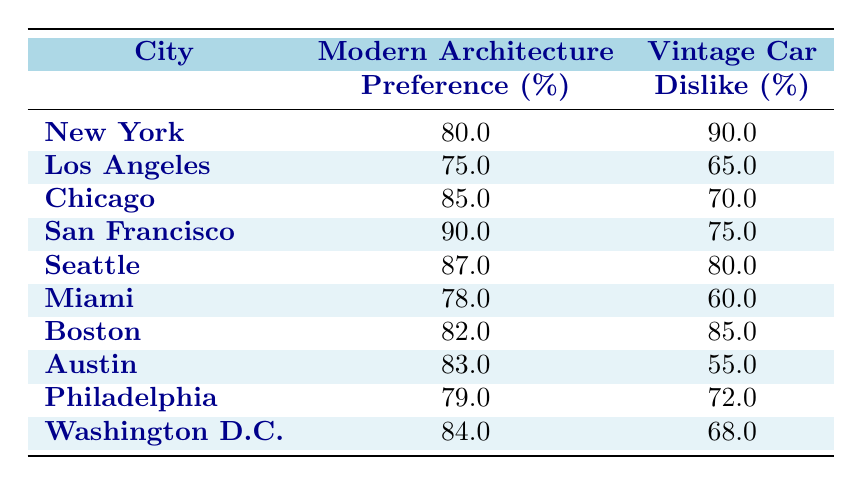What is the modern architecture preference percentage for San Francisco? The table shows that San Francisco has a modern architecture preference of 90%.
Answer: 90.0 What is the vintage car dislike percentage for Miami? According to the table, Miami has a vintage car dislike percentage of 60%.
Answer: 60.0 Which city has the highest vintage car dislike percentage? By looking through the table, New York exhibits the highest vintage car dislike at 90%.
Answer: New York What is the average modern architecture preference percentage across all cities? To find the average, we can add the modern architecture preferences: 80 + 75 + 85 + 90 + 87 + 78 + 82 + 83 + 79 + 84 =  834. There are 10 cities, so the average is 834 / 10 = 83.4.
Answer: 83.4 Are there any cities where modern architecture preference is below 80%? Checking the table, Los Angeles (75%), and Miami (78%) both have modern architecture preferences below 80%. Therefore, the answer is yes.
Answer: Yes Which city has the lowest vintage car dislike percentage? By comparing the percentages, Austin has the lowest vintage car dislike at 55%.
Answer: Austin What is the difference in vintage car dislike percentage between New York and Seattle? The vintage car dislike percentage for New York is 90%, while for Seattle it is 80%. The difference is 90 - 80 = 10.
Answer: 10 Which city has a higher preference for modern architecture, Boston or Washington D.C.? Boston has a modern architecture preference of 82%, while Washington D.C. has 84%. Since 84% is greater than 82%, Washington D.C. has the higher preference.
Answer: Washington D.C How many cities have a vintage car dislike percentage of 70% or higher? From the table, the cities are New York (90%), Chicago (70%), Boston (85%), Seattle (80%), and San Francisco (75%). That makes a total of five cities.
Answer: 5 